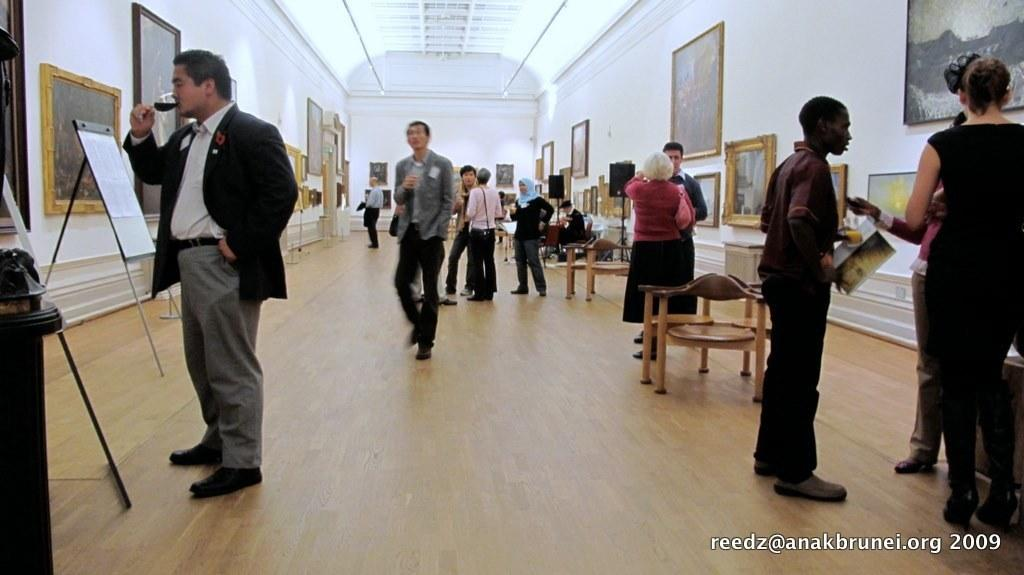Who or what can be seen in the image? There are people in the image. What is on the walls in the image? There are sceneries on both walls. What type of furniture is present in the image? There are chairs in the image. What color is the wall in the background? There is a white color wall in the background. What can be used for displaying information or visuals in the image? There are display boards in the image. Can you see a bee buzzing around the display boards in the image? There is no bee present in the image. What type of cast is performing on the chairs in the image? There is no cast or performance happening in the image; it features people, sceneries, chairs, and display boards. 